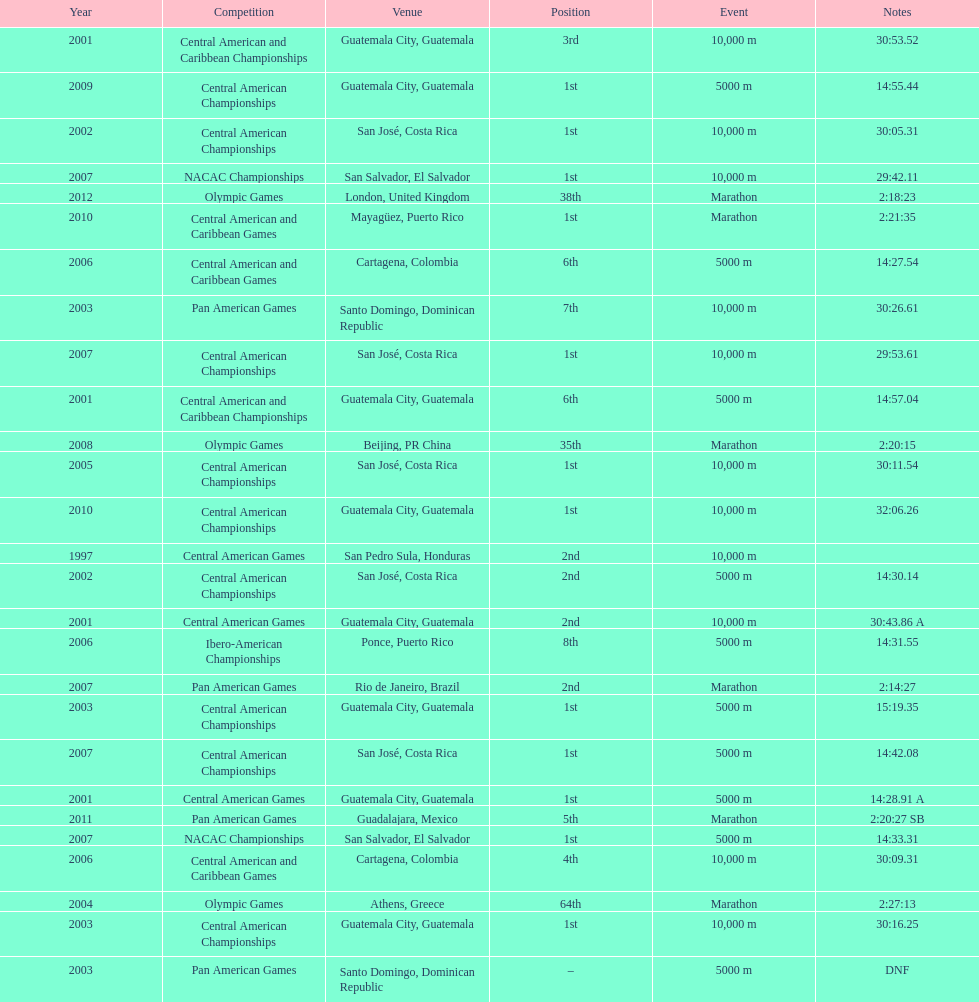Tell me the number of times they competed in guatamala. 5. 